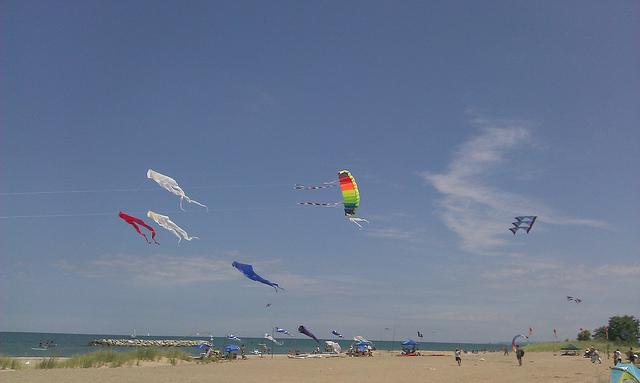Who uses the item in the sky the most? Please explain your reasoning. kids. There are a lot of kids on the beach and running around with kites in the air. it is a windy day you can tell because the tails of the kites are whipping around in air. 